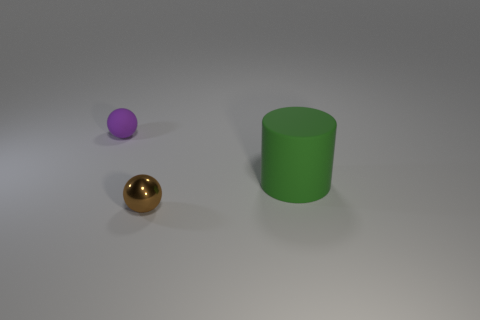Is the material of the tiny ball in front of the tiny purple matte sphere the same as the small object that is behind the small metal object?
Give a very brief answer. No. Is the number of cylinders that are to the left of the matte cylinder greater than the number of tiny spheres on the left side of the small matte object?
Provide a succinct answer. No. What shape is the object that is the same size as the brown sphere?
Offer a terse response. Sphere. How many things are either large gray cylinders or objects that are in front of the small rubber object?
Give a very brief answer. 2. Is the color of the tiny metal object the same as the rubber ball?
Ensure brevity in your answer.  No. How many brown metal objects are in front of the tiny purple rubber thing?
Offer a very short reply. 1. What color is the small ball that is made of the same material as the green thing?
Offer a terse response. Purple. What number of metallic objects are large cylinders or tiny purple things?
Offer a terse response. 0. Is the green thing made of the same material as the small brown sphere?
Provide a short and direct response. No. What shape is the small rubber thing that is behind the cylinder?
Keep it short and to the point. Sphere. 